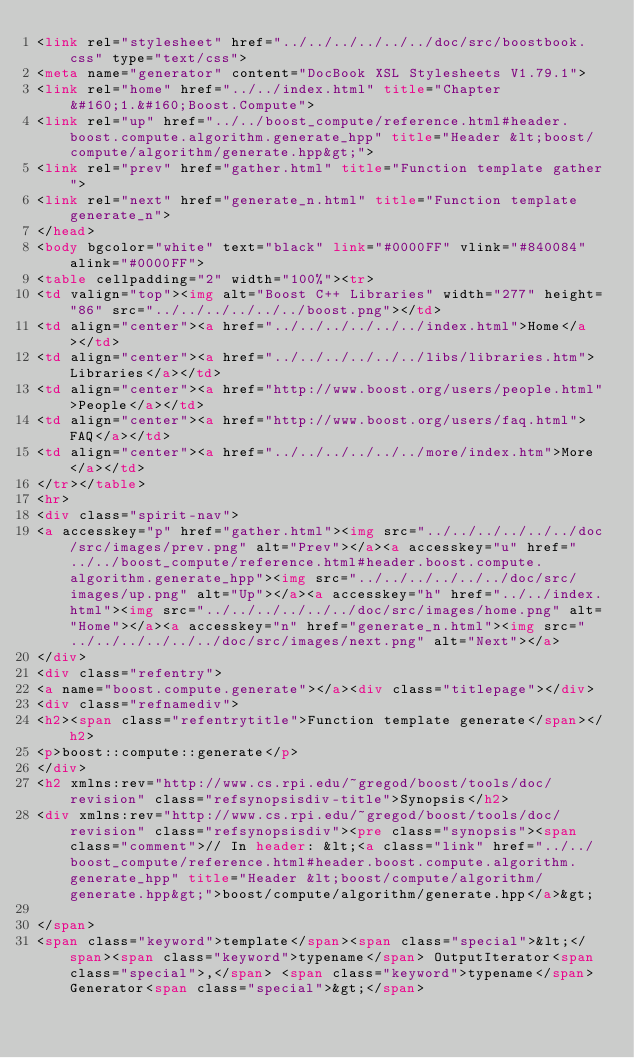<code> <loc_0><loc_0><loc_500><loc_500><_HTML_><link rel="stylesheet" href="../../../../../../doc/src/boostbook.css" type="text/css">
<meta name="generator" content="DocBook XSL Stylesheets V1.79.1">
<link rel="home" href="../../index.html" title="Chapter&#160;1.&#160;Boost.Compute">
<link rel="up" href="../../boost_compute/reference.html#header.boost.compute.algorithm.generate_hpp" title="Header &lt;boost/compute/algorithm/generate.hpp&gt;">
<link rel="prev" href="gather.html" title="Function template gather">
<link rel="next" href="generate_n.html" title="Function template generate_n">
</head>
<body bgcolor="white" text="black" link="#0000FF" vlink="#840084" alink="#0000FF">
<table cellpadding="2" width="100%"><tr>
<td valign="top"><img alt="Boost C++ Libraries" width="277" height="86" src="../../../../../../boost.png"></td>
<td align="center"><a href="../../../../../../index.html">Home</a></td>
<td align="center"><a href="../../../../../../libs/libraries.htm">Libraries</a></td>
<td align="center"><a href="http://www.boost.org/users/people.html">People</a></td>
<td align="center"><a href="http://www.boost.org/users/faq.html">FAQ</a></td>
<td align="center"><a href="../../../../../../more/index.htm">More</a></td>
</tr></table>
<hr>
<div class="spirit-nav">
<a accesskey="p" href="gather.html"><img src="../../../../../../doc/src/images/prev.png" alt="Prev"></a><a accesskey="u" href="../../boost_compute/reference.html#header.boost.compute.algorithm.generate_hpp"><img src="../../../../../../doc/src/images/up.png" alt="Up"></a><a accesskey="h" href="../../index.html"><img src="../../../../../../doc/src/images/home.png" alt="Home"></a><a accesskey="n" href="generate_n.html"><img src="../../../../../../doc/src/images/next.png" alt="Next"></a>
</div>
<div class="refentry">
<a name="boost.compute.generate"></a><div class="titlepage"></div>
<div class="refnamediv">
<h2><span class="refentrytitle">Function template generate</span></h2>
<p>boost::compute::generate</p>
</div>
<h2 xmlns:rev="http://www.cs.rpi.edu/~gregod/boost/tools/doc/revision" class="refsynopsisdiv-title">Synopsis</h2>
<div xmlns:rev="http://www.cs.rpi.edu/~gregod/boost/tools/doc/revision" class="refsynopsisdiv"><pre class="synopsis"><span class="comment">// In header: &lt;<a class="link" href="../../boost_compute/reference.html#header.boost.compute.algorithm.generate_hpp" title="Header &lt;boost/compute/algorithm/generate.hpp&gt;">boost/compute/algorithm/generate.hpp</a>&gt;

</span>
<span class="keyword">template</span><span class="special">&lt;</span><span class="keyword">typename</span> OutputIterator<span class="special">,</span> <span class="keyword">typename</span> Generator<span class="special">&gt;</span> </code> 